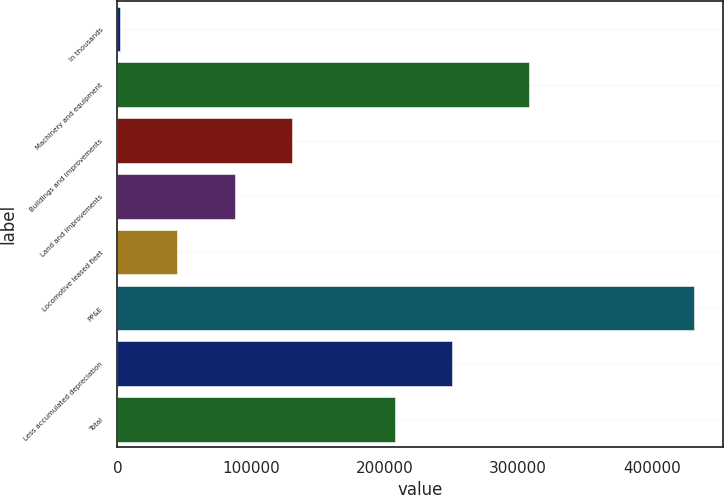Convert chart to OTSL. <chart><loc_0><loc_0><loc_500><loc_500><bar_chart><fcel>In thousands<fcel>Machinery and equipment<fcel>Buildings and improvements<fcel>Land and improvements<fcel>Locomotive leased fleet<fcel>PP&E<fcel>Less accumulated depreciation<fcel>Total<nl><fcel>2008<fcel>308189<fcel>130887<fcel>87927.2<fcel>44967.6<fcel>431604<fcel>250508<fcel>207548<nl></chart> 